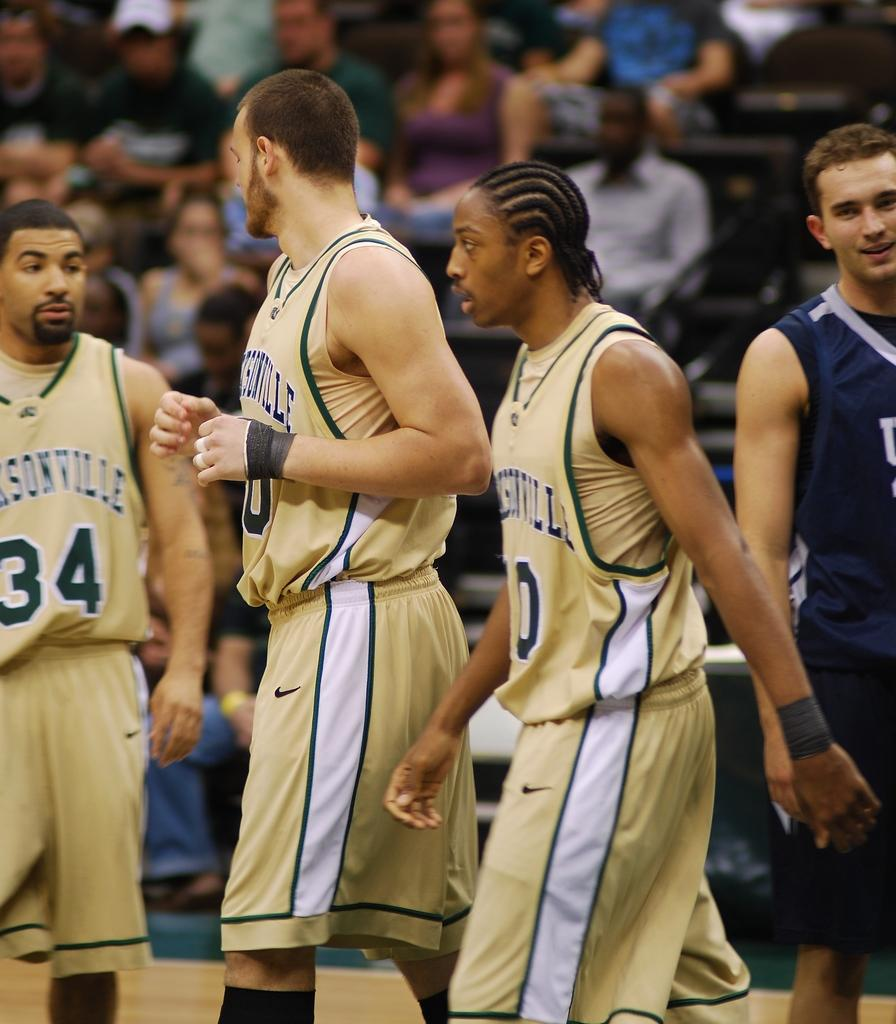<image>
Offer a succinct explanation of the picture presented. Number 34 on the basketball team is competing against the player in blue on the court. 